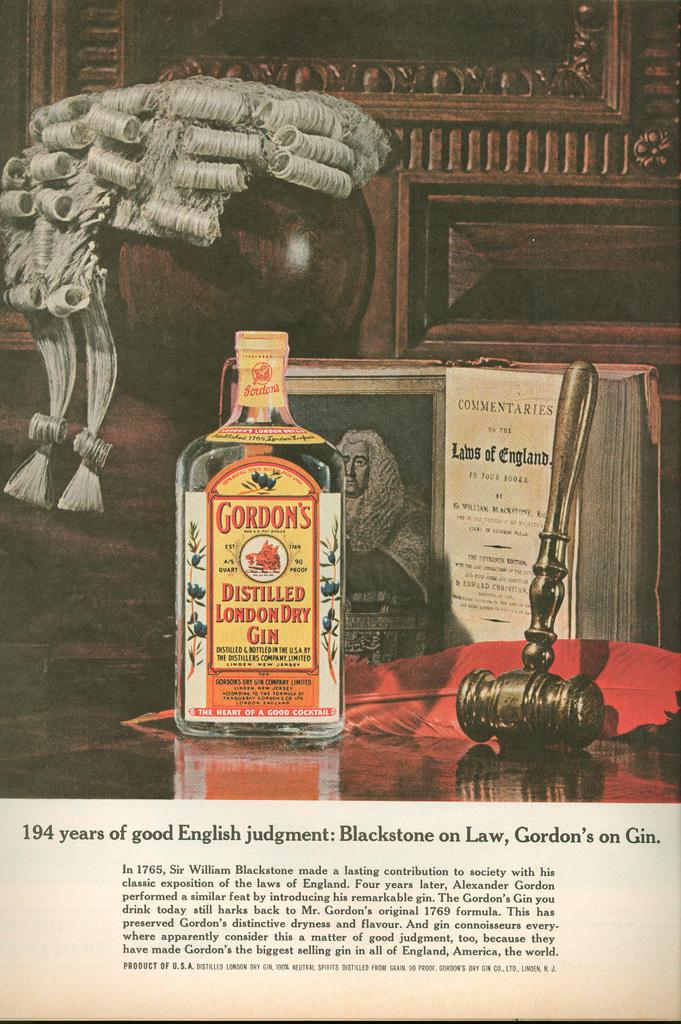How long has the company made gin?
Your response must be concise. 194 years. 